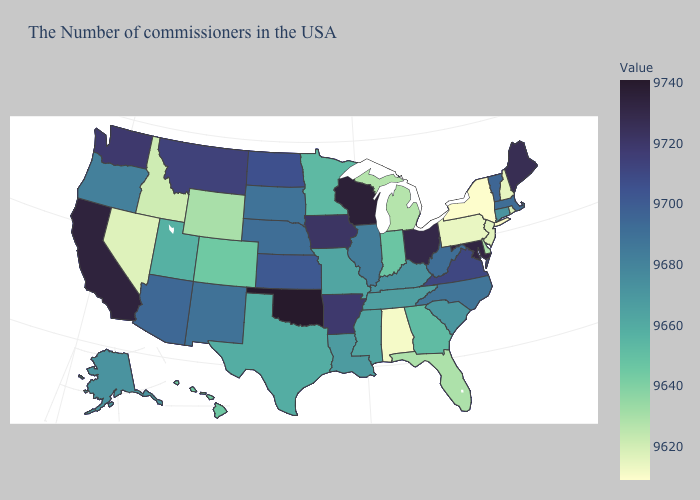Does Oklahoma have the highest value in the USA?
Be succinct. Yes. Which states have the lowest value in the Northeast?
Keep it brief. New York. Does Oklahoma have the highest value in the South?
Keep it brief. Yes. Does Alabama have the lowest value in the South?
Quick response, please. Yes. Does the map have missing data?
Concise answer only. No. Among the states that border Kentucky , which have the highest value?
Quick response, please. Ohio. Among the states that border South Carolina , does North Carolina have the highest value?
Quick response, please. Yes. 